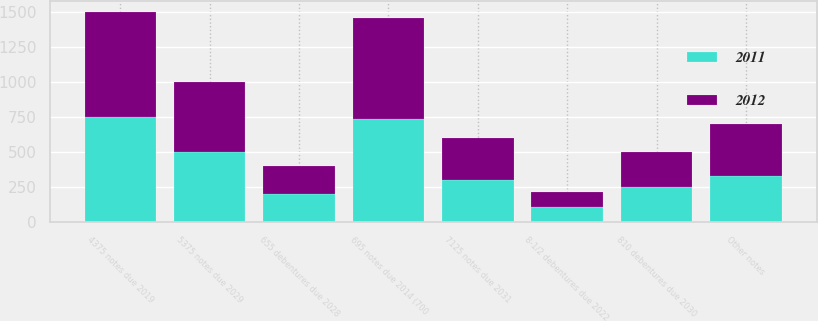Convert chart. <chart><loc_0><loc_0><loc_500><loc_500><stacked_bar_chart><ecel><fcel>695 notes due 2014 (700<fcel>4375 notes due 2019<fcel>8-1/2 debentures due 2022<fcel>655 debentures due 2028<fcel>5375 notes due 2029<fcel>810 debentures due 2030<fcel>7125 notes due 2031<fcel>Other notes<nl><fcel>2012<fcel>718<fcel>750<fcel>105<fcel>200<fcel>500<fcel>250<fcel>300<fcel>372<nl><fcel>2011<fcel>736<fcel>750<fcel>105<fcel>200<fcel>500<fcel>250<fcel>300<fcel>326<nl></chart> 